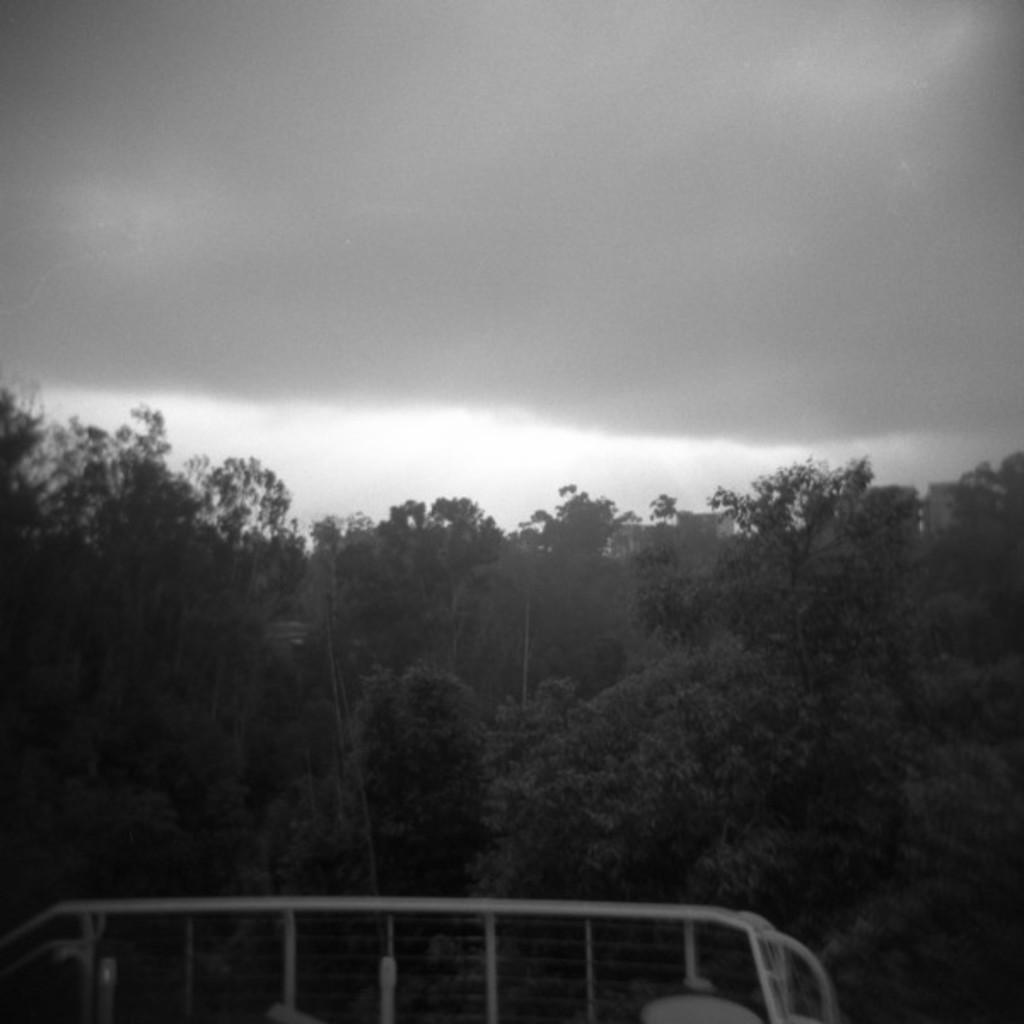In one or two sentences, can you explain what this image depicts? This is a black and white pic. At the bottom we can see the fence. In the background there are trees, buildings and clouds in the sky. 